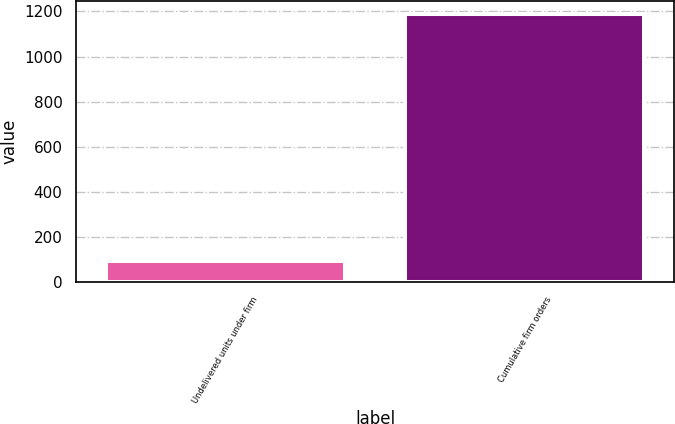Convert chart to OTSL. <chart><loc_0><loc_0><loc_500><loc_500><bar_chart><fcel>Undelivered units under firm<fcel>Cumulative firm orders<nl><fcel>93<fcel>1189<nl></chart> 